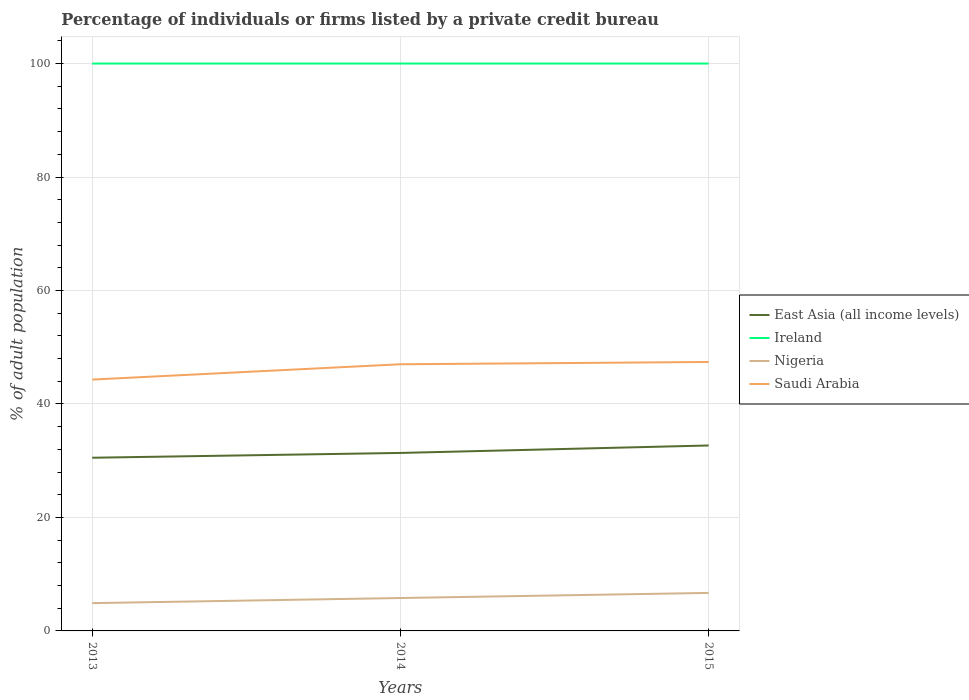How many different coloured lines are there?
Offer a very short reply. 4. Across all years, what is the maximum percentage of population listed by a private credit bureau in Nigeria?
Offer a terse response. 4.9. What is the total percentage of population listed by a private credit bureau in East Asia (all income levels) in the graph?
Give a very brief answer. -0.84. What is the difference between the highest and the second highest percentage of population listed by a private credit bureau in Saudi Arabia?
Ensure brevity in your answer.  3.1. Is the percentage of population listed by a private credit bureau in Saudi Arabia strictly greater than the percentage of population listed by a private credit bureau in Nigeria over the years?
Your answer should be compact. No. How many lines are there?
Provide a succinct answer. 4. Are the values on the major ticks of Y-axis written in scientific E-notation?
Provide a succinct answer. No. Does the graph contain any zero values?
Offer a very short reply. No. What is the title of the graph?
Provide a succinct answer. Percentage of individuals or firms listed by a private credit bureau. Does "Fragile and conflict affected situations" appear as one of the legend labels in the graph?
Your answer should be very brief. No. What is the label or title of the Y-axis?
Your answer should be very brief. % of adult population. What is the % of adult population in East Asia (all income levels) in 2013?
Offer a terse response. 30.52. What is the % of adult population in Ireland in 2013?
Your response must be concise. 100. What is the % of adult population of Nigeria in 2013?
Your response must be concise. 4.9. What is the % of adult population in Saudi Arabia in 2013?
Offer a terse response. 44.3. What is the % of adult population in East Asia (all income levels) in 2014?
Ensure brevity in your answer.  31.37. What is the % of adult population in Ireland in 2014?
Provide a succinct answer. 100. What is the % of adult population in Nigeria in 2014?
Keep it short and to the point. 5.8. What is the % of adult population in East Asia (all income levels) in 2015?
Keep it short and to the point. 32.68. What is the % of adult population of Saudi Arabia in 2015?
Your response must be concise. 47.4. Across all years, what is the maximum % of adult population of East Asia (all income levels)?
Make the answer very short. 32.68. Across all years, what is the maximum % of adult population of Ireland?
Your answer should be very brief. 100. Across all years, what is the maximum % of adult population of Nigeria?
Your answer should be compact. 6.7. Across all years, what is the maximum % of adult population of Saudi Arabia?
Your answer should be very brief. 47.4. Across all years, what is the minimum % of adult population in East Asia (all income levels)?
Your answer should be compact. 30.52. Across all years, what is the minimum % of adult population of Saudi Arabia?
Offer a very short reply. 44.3. What is the total % of adult population in East Asia (all income levels) in the graph?
Offer a terse response. 94.58. What is the total % of adult population of Ireland in the graph?
Offer a very short reply. 300. What is the total % of adult population of Nigeria in the graph?
Your response must be concise. 17.4. What is the total % of adult population of Saudi Arabia in the graph?
Keep it short and to the point. 138.7. What is the difference between the % of adult population in East Asia (all income levels) in 2013 and that in 2014?
Your answer should be very brief. -0.84. What is the difference between the % of adult population of Saudi Arabia in 2013 and that in 2014?
Your response must be concise. -2.7. What is the difference between the % of adult population of East Asia (all income levels) in 2013 and that in 2015?
Ensure brevity in your answer.  -2.16. What is the difference between the % of adult population in Saudi Arabia in 2013 and that in 2015?
Provide a succinct answer. -3.1. What is the difference between the % of adult population in East Asia (all income levels) in 2014 and that in 2015?
Give a very brief answer. -1.31. What is the difference between the % of adult population of Ireland in 2014 and that in 2015?
Keep it short and to the point. 0. What is the difference between the % of adult population of East Asia (all income levels) in 2013 and the % of adult population of Ireland in 2014?
Ensure brevity in your answer.  -69.48. What is the difference between the % of adult population of East Asia (all income levels) in 2013 and the % of adult population of Nigeria in 2014?
Offer a very short reply. 24.72. What is the difference between the % of adult population of East Asia (all income levels) in 2013 and the % of adult population of Saudi Arabia in 2014?
Provide a short and direct response. -16.48. What is the difference between the % of adult population of Ireland in 2013 and the % of adult population of Nigeria in 2014?
Give a very brief answer. 94.2. What is the difference between the % of adult population in Nigeria in 2013 and the % of adult population in Saudi Arabia in 2014?
Your answer should be very brief. -42.1. What is the difference between the % of adult population in East Asia (all income levels) in 2013 and the % of adult population in Ireland in 2015?
Your answer should be very brief. -69.48. What is the difference between the % of adult population of East Asia (all income levels) in 2013 and the % of adult population of Nigeria in 2015?
Offer a terse response. 23.82. What is the difference between the % of adult population in East Asia (all income levels) in 2013 and the % of adult population in Saudi Arabia in 2015?
Provide a succinct answer. -16.88. What is the difference between the % of adult population of Ireland in 2013 and the % of adult population of Nigeria in 2015?
Offer a very short reply. 93.3. What is the difference between the % of adult population in Ireland in 2013 and the % of adult population in Saudi Arabia in 2015?
Provide a succinct answer. 52.6. What is the difference between the % of adult population of Nigeria in 2013 and the % of adult population of Saudi Arabia in 2015?
Provide a succinct answer. -42.5. What is the difference between the % of adult population of East Asia (all income levels) in 2014 and the % of adult population of Ireland in 2015?
Give a very brief answer. -68.63. What is the difference between the % of adult population in East Asia (all income levels) in 2014 and the % of adult population in Nigeria in 2015?
Give a very brief answer. 24.67. What is the difference between the % of adult population in East Asia (all income levels) in 2014 and the % of adult population in Saudi Arabia in 2015?
Your response must be concise. -16.03. What is the difference between the % of adult population in Ireland in 2014 and the % of adult population in Nigeria in 2015?
Offer a very short reply. 93.3. What is the difference between the % of adult population of Ireland in 2014 and the % of adult population of Saudi Arabia in 2015?
Provide a short and direct response. 52.6. What is the difference between the % of adult population in Nigeria in 2014 and the % of adult population in Saudi Arabia in 2015?
Your answer should be very brief. -41.6. What is the average % of adult population in East Asia (all income levels) per year?
Give a very brief answer. 31.53. What is the average % of adult population of Saudi Arabia per year?
Give a very brief answer. 46.23. In the year 2013, what is the difference between the % of adult population in East Asia (all income levels) and % of adult population in Ireland?
Offer a terse response. -69.48. In the year 2013, what is the difference between the % of adult population of East Asia (all income levels) and % of adult population of Nigeria?
Your answer should be very brief. 25.62. In the year 2013, what is the difference between the % of adult population of East Asia (all income levels) and % of adult population of Saudi Arabia?
Provide a succinct answer. -13.78. In the year 2013, what is the difference between the % of adult population in Ireland and % of adult population in Nigeria?
Offer a very short reply. 95.1. In the year 2013, what is the difference between the % of adult population in Ireland and % of adult population in Saudi Arabia?
Your answer should be very brief. 55.7. In the year 2013, what is the difference between the % of adult population in Nigeria and % of adult population in Saudi Arabia?
Offer a terse response. -39.4. In the year 2014, what is the difference between the % of adult population of East Asia (all income levels) and % of adult population of Ireland?
Ensure brevity in your answer.  -68.63. In the year 2014, what is the difference between the % of adult population in East Asia (all income levels) and % of adult population in Nigeria?
Your answer should be compact. 25.57. In the year 2014, what is the difference between the % of adult population of East Asia (all income levels) and % of adult population of Saudi Arabia?
Ensure brevity in your answer.  -15.63. In the year 2014, what is the difference between the % of adult population in Ireland and % of adult population in Nigeria?
Your answer should be compact. 94.2. In the year 2014, what is the difference between the % of adult population of Nigeria and % of adult population of Saudi Arabia?
Ensure brevity in your answer.  -41.2. In the year 2015, what is the difference between the % of adult population in East Asia (all income levels) and % of adult population in Ireland?
Keep it short and to the point. -67.32. In the year 2015, what is the difference between the % of adult population in East Asia (all income levels) and % of adult population in Nigeria?
Ensure brevity in your answer.  25.98. In the year 2015, what is the difference between the % of adult population in East Asia (all income levels) and % of adult population in Saudi Arabia?
Keep it short and to the point. -14.72. In the year 2015, what is the difference between the % of adult population of Ireland and % of adult population of Nigeria?
Offer a terse response. 93.3. In the year 2015, what is the difference between the % of adult population of Ireland and % of adult population of Saudi Arabia?
Provide a succinct answer. 52.6. In the year 2015, what is the difference between the % of adult population of Nigeria and % of adult population of Saudi Arabia?
Give a very brief answer. -40.7. What is the ratio of the % of adult population of East Asia (all income levels) in 2013 to that in 2014?
Ensure brevity in your answer.  0.97. What is the ratio of the % of adult population in Nigeria in 2013 to that in 2014?
Offer a very short reply. 0.84. What is the ratio of the % of adult population in Saudi Arabia in 2013 to that in 2014?
Keep it short and to the point. 0.94. What is the ratio of the % of adult population of East Asia (all income levels) in 2013 to that in 2015?
Ensure brevity in your answer.  0.93. What is the ratio of the % of adult population in Nigeria in 2013 to that in 2015?
Your response must be concise. 0.73. What is the ratio of the % of adult population of Saudi Arabia in 2013 to that in 2015?
Keep it short and to the point. 0.93. What is the ratio of the % of adult population of East Asia (all income levels) in 2014 to that in 2015?
Make the answer very short. 0.96. What is the ratio of the % of adult population of Ireland in 2014 to that in 2015?
Provide a succinct answer. 1. What is the ratio of the % of adult population of Nigeria in 2014 to that in 2015?
Provide a short and direct response. 0.87. What is the difference between the highest and the second highest % of adult population in East Asia (all income levels)?
Ensure brevity in your answer.  1.31. What is the difference between the highest and the second highest % of adult population of Ireland?
Provide a succinct answer. 0. What is the difference between the highest and the second highest % of adult population in Nigeria?
Make the answer very short. 0.9. What is the difference between the highest and the second highest % of adult population in Saudi Arabia?
Make the answer very short. 0.4. What is the difference between the highest and the lowest % of adult population in East Asia (all income levels)?
Offer a terse response. 2.16. What is the difference between the highest and the lowest % of adult population in Ireland?
Your answer should be compact. 0. 